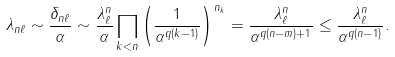Convert formula to latex. <formula><loc_0><loc_0><loc_500><loc_500>\lambda _ { n \ell } \sim \frac { \delta _ { n \ell } } { \alpha } \sim \frac { \lambda _ { \ell } ^ { n } } { \alpha } \prod _ { k < n } \left ( \frac { 1 } { \alpha ^ { q ( k - 1 ) } } \right ) ^ { n _ { k } } = \frac { \lambda _ { \ell } ^ { n } } { \alpha ^ { q ( n - m ) + 1 } } \leq \frac { \lambda _ { \ell } ^ { n } } { \alpha ^ { q ( n - 1 ) } } .</formula> 